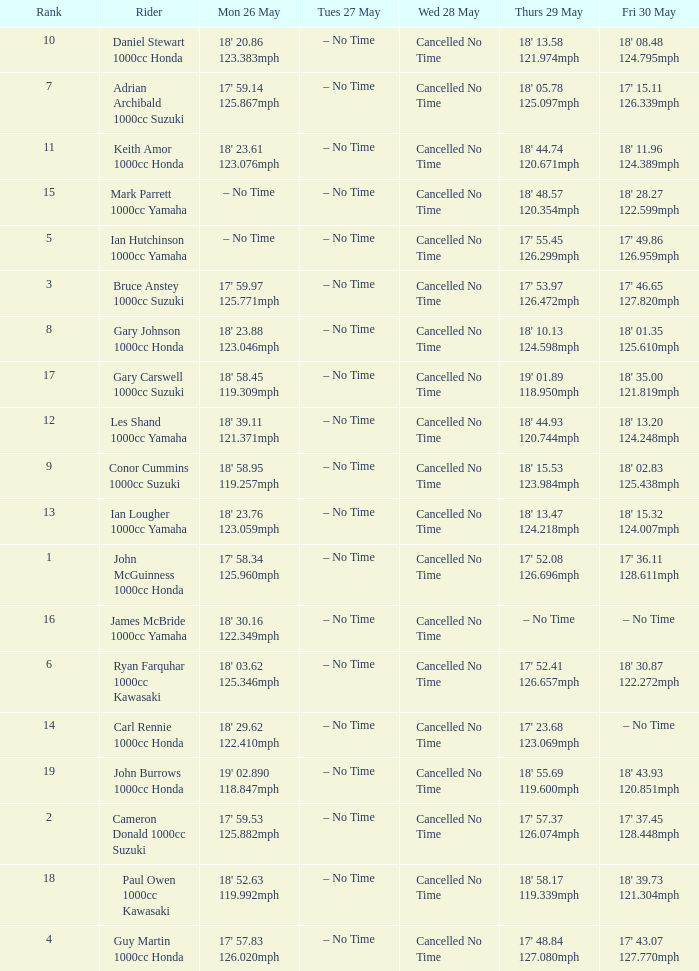What time is mon may 26 and fri may 30 is 18' 28.27 122.599mph? – No Time. 